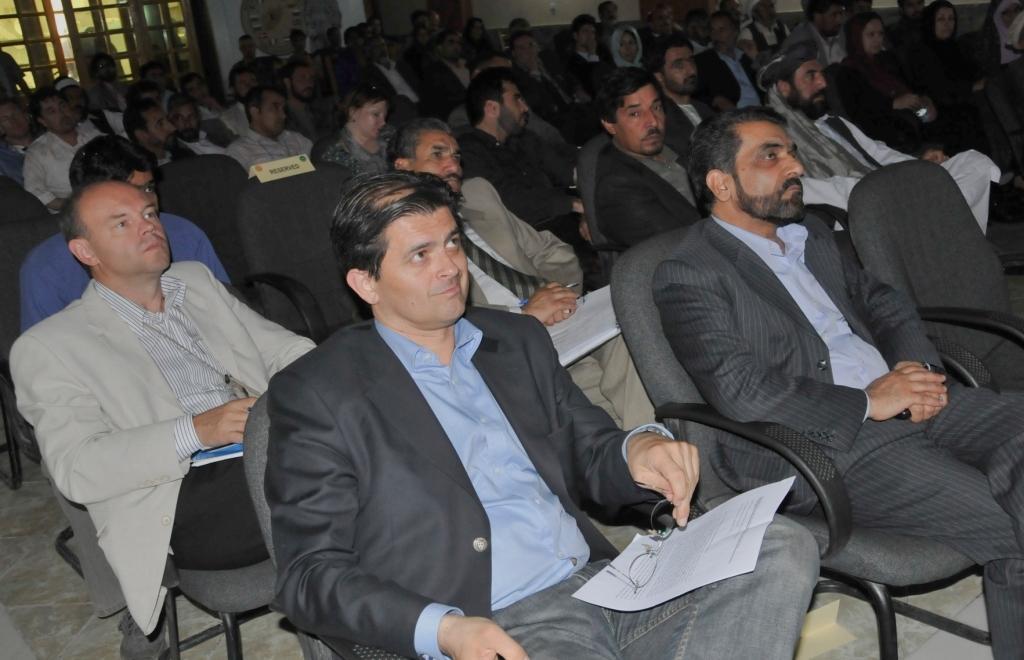Describe this image in one or two sentences. In this image there are many people sitting on the chairs. On the right there is a man he wear suit, shirt and trouser he is staring at something. On the left there is a man he wear shirt, suit and trouser he is sitting on the chair. I think a meeting is going on. 